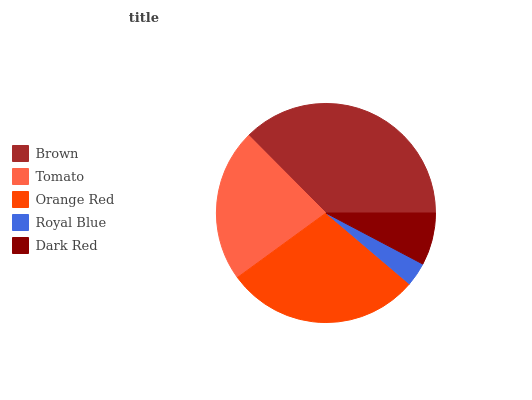Is Royal Blue the minimum?
Answer yes or no. Yes. Is Brown the maximum?
Answer yes or no. Yes. Is Tomato the minimum?
Answer yes or no. No. Is Tomato the maximum?
Answer yes or no. No. Is Brown greater than Tomato?
Answer yes or no. Yes. Is Tomato less than Brown?
Answer yes or no. Yes. Is Tomato greater than Brown?
Answer yes or no. No. Is Brown less than Tomato?
Answer yes or no. No. Is Tomato the high median?
Answer yes or no. Yes. Is Tomato the low median?
Answer yes or no. Yes. Is Royal Blue the high median?
Answer yes or no. No. Is Brown the low median?
Answer yes or no. No. 